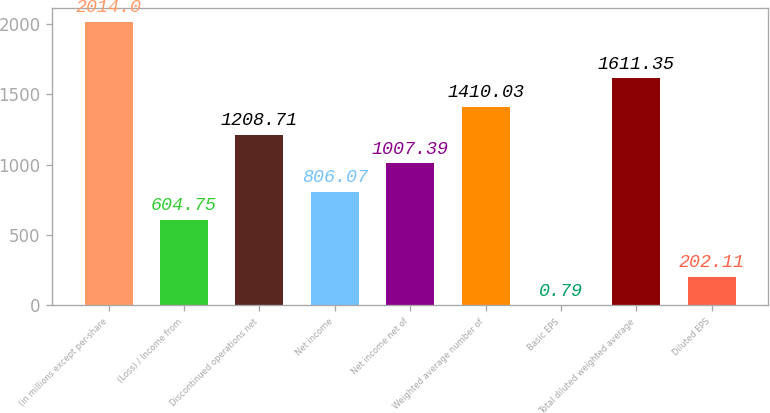Convert chart. <chart><loc_0><loc_0><loc_500><loc_500><bar_chart><fcel>(in millions except per-share<fcel>(Loss) / Income from<fcel>Discontinued operations net<fcel>Net income<fcel>Net income net of<fcel>Weighted average number of<fcel>Basic EPS<fcel>Total diluted weighted average<fcel>Diluted EPS<nl><fcel>2014<fcel>604.75<fcel>1208.71<fcel>806.07<fcel>1007.39<fcel>1410.03<fcel>0.79<fcel>1611.35<fcel>202.11<nl></chart> 